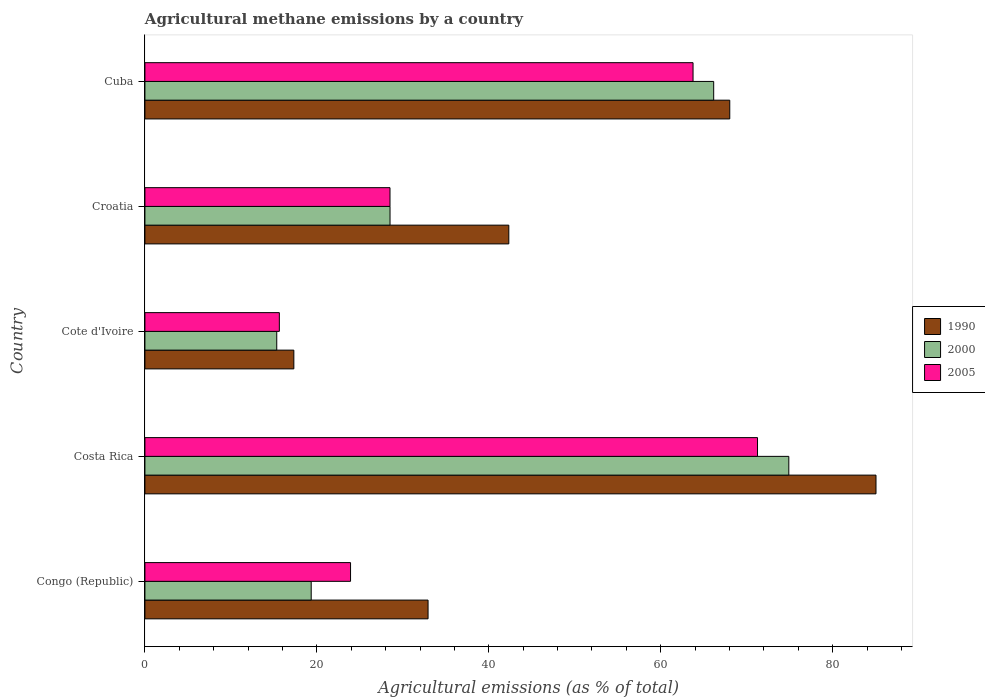How many bars are there on the 1st tick from the bottom?
Keep it short and to the point. 3. What is the label of the 1st group of bars from the top?
Provide a short and direct response. Cuba. In how many cases, is the number of bars for a given country not equal to the number of legend labels?
Your answer should be very brief. 0. What is the amount of agricultural methane emitted in 2000 in Croatia?
Provide a short and direct response. 28.51. Across all countries, what is the maximum amount of agricultural methane emitted in 2000?
Your answer should be very brief. 74.89. Across all countries, what is the minimum amount of agricultural methane emitted in 2000?
Offer a terse response. 15.33. In which country was the amount of agricultural methane emitted in 1990 minimum?
Give a very brief answer. Cote d'Ivoire. What is the total amount of agricultural methane emitted in 2000 in the graph?
Offer a very short reply. 204.24. What is the difference between the amount of agricultural methane emitted in 2000 in Cote d'Ivoire and that in Cuba?
Your response must be concise. -50.82. What is the difference between the amount of agricultural methane emitted in 2005 in Congo (Republic) and the amount of agricultural methane emitted in 1990 in Costa Rica?
Make the answer very short. -61.12. What is the average amount of agricultural methane emitted in 2005 per country?
Provide a short and direct response. 40.61. What is the difference between the amount of agricultural methane emitted in 2000 and amount of agricultural methane emitted in 2005 in Costa Rica?
Your answer should be very brief. 3.64. In how many countries, is the amount of agricultural methane emitted in 2005 greater than 64 %?
Keep it short and to the point. 1. What is the ratio of the amount of agricultural methane emitted in 2005 in Costa Rica to that in Cote d'Ivoire?
Keep it short and to the point. 4.56. Is the amount of agricultural methane emitted in 2000 in Congo (Republic) less than that in Croatia?
Provide a short and direct response. Yes. Is the difference between the amount of agricultural methane emitted in 2000 in Cote d'Ivoire and Croatia greater than the difference between the amount of agricultural methane emitted in 2005 in Cote d'Ivoire and Croatia?
Your answer should be very brief. No. What is the difference between the highest and the second highest amount of agricultural methane emitted in 2005?
Provide a succinct answer. 7.5. What is the difference between the highest and the lowest amount of agricultural methane emitted in 2005?
Your response must be concise. 55.62. In how many countries, is the amount of agricultural methane emitted in 1990 greater than the average amount of agricultural methane emitted in 1990 taken over all countries?
Provide a succinct answer. 2. Is the sum of the amount of agricultural methane emitted in 1990 in Congo (Republic) and Costa Rica greater than the maximum amount of agricultural methane emitted in 2005 across all countries?
Your answer should be compact. Yes. What does the 3rd bar from the bottom in Cuba represents?
Offer a terse response. 2005. How many bars are there?
Your answer should be compact. 15. Are all the bars in the graph horizontal?
Offer a terse response. Yes. How many countries are there in the graph?
Offer a very short reply. 5. Are the values on the major ticks of X-axis written in scientific E-notation?
Give a very brief answer. No. How many legend labels are there?
Your response must be concise. 3. How are the legend labels stacked?
Keep it short and to the point. Vertical. What is the title of the graph?
Keep it short and to the point. Agricultural methane emissions by a country. Does "1993" appear as one of the legend labels in the graph?
Keep it short and to the point. No. What is the label or title of the X-axis?
Keep it short and to the point. Agricultural emissions (as % of total). What is the Agricultural emissions (as % of total) in 1990 in Congo (Republic)?
Provide a succinct answer. 32.93. What is the Agricultural emissions (as % of total) of 2000 in Congo (Republic)?
Offer a very short reply. 19.34. What is the Agricultural emissions (as % of total) of 2005 in Congo (Republic)?
Give a very brief answer. 23.92. What is the Agricultural emissions (as % of total) of 1990 in Costa Rica?
Your answer should be very brief. 85.04. What is the Agricultural emissions (as % of total) in 2000 in Costa Rica?
Make the answer very short. 74.89. What is the Agricultural emissions (as % of total) of 2005 in Costa Rica?
Make the answer very short. 71.26. What is the Agricultural emissions (as % of total) in 1990 in Cote d'Ivoire?
Provide a succinct answer. 17.32. What is the Agricultural emissions (as % of total) in 2000 in Cote d'Ivoire?
Your response must be concise. 15.33. What is the Agricultural emissions (as % of total) in 2005 in Cote d'Ivoire?
Offer a terse response. 15.64. What is the Agricultural emissions (as % of total) of 1990 in Croatia?
Offer a terse response. 42.33. What is the Agricultural emissions (as % of total) of 2000 in Croatia?
Give a very brief answer. 28.51. What is the Agricultural emissions (as % of total) of 2005 in Croatia?
Offer a very short reply. 28.51. What is the Agricultural emissions (as % of total) of 1990 in Cuba?
Offer a terse response. 68.03. What is the Agricultural emissions (as % of total) in 2000 in Cuba?
Give a very brief answer. 66.16. What is the Agricultural emissions (as % of total) in 2005 in Cuba?
Your answer should be very brief. 63.76. Across all countries, what is the maximum Agricultural emissions (as % of total) of 1990?
Your answer should be compact. 85.04. Across all countries, what is the maximum Agricultural emissions (as % of total) of 2000?
Provide a short and direct response. 74.89. Across all countries, what is the maximum Agricultural emissions (as % of total) in 2005?
Your response must be concise. 71.26. Across all countries, what is the minimum Agricultural emissions (as % of total) in 1990?
Ensure brevity in your answer.  17.32. Across all countries, what is the minimum Agricultural emissions (as % of total) in 2000?
Give a very brief answer. 15.33. Across all countries, what is the minimum Agricultural emissions (as % of total) of 2005?
Your answer should be compact. 15.64. What is the total Agricultural emissions (as % of total) in 1990 in the graph?
Ensure brevity in your answer.  245.65. What is the total Agricultural emissions (as % of total) in 2000 in the graph?
Offer a terse response. 204.24. What is the total Agricultural emissions (as % of total) in 2005 in the graph?
Keep it short and to the point. 203.07. What is the difference between the Agricultural emissions (as % of total) of 1990 in Congo (Republic) and that in Costa Rica?
Provide a succinct answer. -52.1. What is the difference between the Agricultural emissions (as % of total) of 2000 in Congo (Republic) and that in Costa Rica?
Provide a succinct answer. -55.55. What is the difference between the Agricultural emissions (as % of total) in 2005 in Congo (Republic) and that in Costa Rica?
Ensure brevity in your answer.  -47.34. What is the difference between the Agricultural emissions (as % of total) in 1990 in Congo (Republic) and that in Cote d'Ivoire?
Your answer should be compact. 15.61. What is the difference between the Agricultural emissions (as % of total) in 2000 in Congo (Republic) and that in Cote d'Ivoire?
Give a very brief answer. 4.01. What is the difference between the Agricultural emissions (as % of total) in 2005 in Congo (Republic) and that in Cote d'Ivoire?
Give a very brief answer. 8.28. What is the difference between the Agricultural emissions (as % of total) of 1990 in Congo (Republic) and that in Croatia?
Give a very brief answer. -9.39. What is the difference between the Agricultural emissions (as % of total) of 2000 in Congo (Republic) and that in Croatia?
Give a very brief answer. -9.17. What is the difference between the Agricultural emissions (as % of total) of 2005 in Congo (Republic) and that in Croatia?
Your response must be concise. -4.59. What is the difference between the Agricultural emissions (as % of total) of 1990 in Congo (Republic) and that in Cuba?
Give a very brief answer. -35.09. What is the difference between the Agricultural emissions (as % of total) in 2000 in Congo (Republic) and that in Cuba?
Ensure brevity in your answer.  -46.81. What is the difference between the Agricultural emissions (as % of total) of 2005 in Congo (Republic) and that in Cuba?
Give a very brief answer. -39.84. What is the difference between the Agricultural emissions (as % of total) in 1990 in Costa Rica and that in Cote d'Ivoire?
Your answer should be very brief. 67.71. What is the difference between the Agricultural emissions (as % of total) in 2000 in Costa Rica and that in Cote d'Ivoire?
Keep it short and to the point. 59.56. What is the difference between the Agricultural emissions (as % of total) in 2005 in Costa Rica and that in Cote d'Ivoire?
Give a very brief answer. 55.62. What is the difference between the Agricultural emissions (as % of total) of 1990 in Costa Rica and that in Croatia?
Your answer should be very brief. 42.71. What is the difference between the Agricultural emissions (as % of total) of 2000 in Costa Rica and that in Croatia?
Your response must be concise. 46.38. What is the difference between the Agricultural emissions (as % of total) of 2005 in Costa Rica and that in Croatia?
Your response must be concise. 42.75. What is the difference between the Agricultural emissions (as % of total) in 1990 in Costa Rica and that in Cuba?
Provide a short and direct response. 17.01. What is the difference between the Agricultural emissions (as % of total) in 2000 in Costa Rica and that in Cuba?
Give a very brief answer. 8.74. What is the difference between the Agricultural emissions (as % of total) of 2005 in Costa Rica and that in Cuba?
Make the answer very short. 7.5. What is the difference between the Agricultural emissions (as % of total) of 1990 in Cote d'Ivoire and that in Croatia?
Give a very brief answer. -25. What is the difference between the Agricultural emissions (as % of total) in 2000 in Cote d'Ivoire and that in Croatia?
Ensure brevity in your answer.  -13.18. What is the difference between the Agricultural emissions (as % of total) in 2005 in Cote d'Ivoire and that in Croatia?
Make the answer very short. -12.87. What is the difference between the Agricultural emissions (as % of total) in 1990 in Cote d'Ivoire and that in Cuba?
Keep it short and to the point. -50.7. What is the difference between the Agricultural emissions (as % of total) in 2000 in Cote d'Ivoire and that in Cuba?
Provide a short and direct response. -50.82. What is the difference between the Agricultural emissions (as % of total) of 2005 in Cote d'Ivoire and that in Cuba?
Make the answer very short. -48.12. What is the difference between the Agricultural emissions (as % of total) of 1990 in Croatia and that in Cuba?
Make the answer very short. -25.7. What is the difference between the Agricultural emissions (as % of total) in 2000 in Croatia and that in Cuba?
Provide a short and direct response. -37.65. What is the difference between the Agricultural emissions (as % of total) in 2005 in Croatia and that in Cuba?
Provide a short and direct response. -35.25. What is the difference between the Agricultural emissions (as % of total) in 1990 in Congo (Republic) and the Agricultural emissions (as % of total) in 2000 in Costa Rica?
Your response must be concise. -41.96. What is the difference between the Agricultural emissions (as % of total) in 1990 in Congo (Republic) and the Agricultural emissions (as % of total) in 2005 in Costa Rica?
Keep it short and to the point. -38.32. What is the difference between the Agricultural emissions (as % of total) in 2000 in Congo (Republic) and the Agricultural emissions (as % of total) in 2005 in Costa Rica?
Offer a terse response. -51.91. What is the difference between the Agricultural emissions (as % of total) in 1990 in Congo (Republic) and the Agricultural emissions (as % of total) in 2000 in Cote d'Ivoire?
Provide a short and direct response. 17.6. What is the difference between the Agricultural emissions (as % of total) of 1990 in Congo (Republic) and the Agricultural emissions (as % of total) of 2005 in Cote d'Ivoire?
Ensure brevity in your answer.  17.3. What is the difference between the Agricultural emissions (as % of total) in 2000 in Congo (Republic) and the Agricultural emissions (as % of total) in 2005 in Cote d'Ivoire?
Offer a very short reply. 3.71. What is the difference between the Agricultural emissions (as % of total) in 1990 in Congo (Republic) and the Agricultural emissions (as % of total) in 2000 in Croatia?
Ensure brevity in your answer.  4.42. What is the difference between the Agricultural emissions (as % of total) in 1990 in Congo (Republic) and the Agricultural emissions (as % of total) in 2005 in Croatia?
Offer a very short reply. 4.43. What is the difference between the Agricultural emissions (as % of total) of 2000 in Congo (Republic) and the Agricultural emissions (as % of total) of 2005 in Croatia?
Provide a succinct answer. -9.16. What is the difference between the Agricultural emissions (as % of total) of 1990 in Congo (Republic) and the Agricultural emissions (as % of total) of 2000 in Cuba?
Offer a terse response. -33.22. What is the difference between the Agricultural emissions (as % of total) in 1990 in Congo (Republic) and the Agricultural emissions (as % of total) in 2005 in Cuba?
Provide a succinct answer. -30.82. What is the difference between the Agricultural emissions (as % of total) of 2000 in Congo (Republic) and the Agricultural emissions (as % of total) of 2005 in Cuba?
Keep it short and to the point. -44.41. What is the difference between the Agricultural emissions (as % of total) of 1990 in Costa Rica and the Agricultural emissions (as % of total) of 2000 in Cote d'Ivoire?
Your answer should be compact. 69.7. What is the difference between the Agricultural emissions (as % of total) of 1990 in Costa Rica and the Agricultural emissions (as % of total) of 2005 in Cote d'Ivoire?
Give a very brief answer. 69.4. What is the difference between the Agricultural emissions (as % of total) of 2000 in Costa Rica and the Agricultural emissions (as % of total) of 2005 in Cote d'Ivoire?
Make the answer very short. 59.26. What is the difference between the Agricultural emissions (as % of total) of 1990 in Costa Rica and the Agricultural emissions (as % of total) of 2000 in Croatia?
Your response must be concise. 56.53. What is the difference between the Agricultural emissions (as % of total) in 1990 in Costa Rica and the Agricultural emissions (as % of total) in 2005 in Croatia?
Offer a terse response. 56.53. What is the difference between the Agricultural emissions (as % of total) in 2000 in Costa Rica and the Agricultural emissions (as % of total) in 2005 in Croatia?
Make the answer very short. 46.39. What is the difference between the Agricultural emissions (as % of total) in 1990 in Costa Rica and the Agricultural emissions (as % of total) in 2000 in Cuba?
Offer a very short reply. 18.88. What is the difference between the Agricultural emissions (as % of total) in 1990 in Costa Rica and the Agricultural emissions (as % of total) in 2005 in Cuba?
Offer a terse response. 21.28. What is the difference between the Agricultural emissions (as % of total) of 2000 in Costa Rica and the Agricultural emissions (as % of total) of 2005 in Cuba?
Give a very brief answer. 11.14. What is the difference between the Agricultural emissions (as % of total) in 1990 in Cote d'Ivoire and the Agricultural emissions (as % of total) in 2000 in Croatia?
Provide a succinct answer. -11.19. What is the difference between the Agricultural emissions (as % of total) of 1990 in Cote d'Ivoire and the Agricultural emissions (as % of total) of 2005 in Croatia?
Offer a terse response. -11.18. What is the difference between the Agricultural emissions (as % of total) in 2000 in Cote d'Ivoire and the Agricultural emissions (as % of total) in 2005 in Croatia?
Make the answer very short. -13.17. What is the difference between the Agricultural emissions (as % of total) of 1990 in Cote d'Ivoire and the Agricultural emissions (as % of total) of 2000 in Cuba?
Provide a succinct answer. -48.83. What is the difference between the Agricultural emissions (as % of total) in 1990 in Cote d'Ivoire and the Agricultural emissions (as % of total) in 2005 in Cuba?
Make the answer very short. -46.43. What is the difference between the Agricultural emissions (as % of total) of 2000 in Cote d'Ivoire and the Agricultural emissions (as % of total) of 2005 in Cuba?
Your response must be concise. -48.42. What is the difference between the Agricultural emissions (as % of total) in 1990 in Croatia and the Agricultural emissions (as % of total) in 2000 in Cuba?
Offer a very short reply. -23.83. What is the difference between the Agricultural emissions (as % of total) in 1990 in Croatia and the Agricultural emissions (as % of total) in 2005 in Cuba?
Provide a short and direct response. -21.43. What is the difference between the Agricultural emissions (as % of total) of 2000 in Croatia and the Agricultural emissions (as % of total) of 2005 in Cuba?
Provide a short and direct response. -35.24. What is the average Agricultural emissions (as % of total) in 1990 per country?
Your answer should be very brief. 49.13. What is the average Agricultural emissions (as % of total) in 2000 per country?
Provide a succinct answer. 40.85. What is the average Agricultural emissions (as % of total) in 2005 per country?
Your response must be concise. 40.61. What is the difference between the Agricultural emissions (as % of total) of 1990 and Agricultural emissions (as % of total) of 2000 in Congo (Republic)?
Your answer should be very brief. 13.59. What is the difference between the Agricultural emissions (as % of total) of 1990 and Agricultural emissions (as % of total) of 2005 in Congo (Republic)?
Give a very brief answer. 9.02. What is the difference between the Agricultural emissions (as % of total) of 2000 and Agricultural emissions (as % of total) of 2005 in Congo (Republic)?
Keep it short and to the point. -4.58. What is the difference between the Agricultural emissions (as % of total) in 1990 and Agricultural emissions (as % of total) in 2000 in Costa Rica?
Keep it short and to the point. 10.14. What is the difference between the Agricultural emissions (as % of total) of 1990 and Agricultural emissions (as % of total) of 2005 in Costa Rica?
Make the answer very short. 13.78. What is the difference between the Agricultural emissions (as % of total) in 2000 and Agricultural emissions (as % of total) in 2005 in Costa Rica?
Your answer should be compact. 3.64. What is the difference between the Agricultural emissions (as % of total) in 1990 and Agricultural emissions (as % of total) in 2000 in Cote d'Ivoire?
Ensure brevity in your answer.  1.99. What is the difference between the Agricultural emissions (as % of total) of 1990 and Agricultural emissions (as % of total) of 2005 in Cote d'Ivoire?
Your answer should be very brief. 1.69. What is the difference between the Agricultural emissions (as % of total) of 2000 and Agricultural emissions (as % of total) of 2005 in Cote d'Ivoire?
Give a very brief answer. -0.3. What is the difference between the Agricultural emissions (as % of total) of 1990 and Agricultural emissions (as % of total) of 2000 in Croatia?
Ensure brevity in your answer.  13.82. What is the difference between the Agricultural emissions (as % of total) of 1990 and Agricultural emissions (as % of total) of 2005 in Croatia?
Keep it short and to the point. 13.82. What is the difference between the Agricultural emissions (as % of total) of 2000 and Agricultural emissions (as % of total) of 2005 in Croatia?
Ensure brevity in your answer.  0. What is the difference between the Agricultural emissions (as % of total) of 1990 and Agricultural emissions (as % of total) of 2000 in Cuba?
Offer a terse response. 1.87. What is the difference between the Agricultural emissions (as % of total) in 1990 and Agricultural emissions (as % of total) in 2005 in Cuba?
Your answer should be very brief. 4.27. What is the difference between the Agricultural emissions (as % of total) in 2000 and Agricultural emissions (as % of total) in 2005 in Cuba?
Give a very brief answer. 2.4. What is the ratio of the Agricultural emissions (as % of total) in 1990 in Congo (Republic) to that in Costa Rica?
Provide a short and direct response. 0.39. What is the ratio of the Agricultural emissions (as % of total) of 2000 in Congo (Republic) to that in Costa Rica?
Make the answer very short. 0.26. What is the ratio of the Agricultural emissions (as % of total) in 2005 in Congo (Republic) to that in Costa Rica?
Your answer should be compact. 0.34. What is the ratio of the Agricultural emissions (as % of total) in 1990 in Congo (Republic) to that in Cote d'Ivoire?
Provide a short and direct response. 1.9. What is the ratio of the Agricultural emissions (as % of total) of 2000 in Congo (Republic) to that in Cote d'Ivoire?
Keep it short and to the point. 1.26. What is the ratio of the Agricultural emissions (as % of total) of 2005 in Congo (Republic) to that in Cote d'Ivoire?
Offer a terse response. 1.53. What is the ratio of the Agricultural emissions (as % of total) in 1990 in Congo (Republic) to that in Croatia?
Offer a very short reply. 0.78. What is the ratio of the Agricultural emissions (as % of total) in 2000 in Congo (Republic) to that in Croatia?
Make the answer very short. 0.68. What is the ratio of the Agricultural emissions (as % of total) of 2005 in Congo (Republic) to that in Croatia?
Your response must be concise. 0.84. What is the ratio of the Agricultural emissions (as % of total) in 1990 in Congo (Republic) to that in Cuba?
Ensure brevity in your answer.  0.48. What is the ratio of the Agricultural emissions (as % of total) of 2000 in Congo (Republic) to that in Cuba?
Offer a terse response. 0.29. What is the ratio of the Agricultural emissions (as % of total) in 2005 in Congo (Republic) to that in Cuba?
Provide a succinct answer. 0.38. What is the ratio of the Agricultural emissions (as % of total) of 1990 in Costa Rica to that in Cote d'Ivoire?
Your answer should be compact. 4.91. What is the ratio of the Agricultural emissions (as % of total) of 2000 in Costa Rica to that in Cote d'Ivoire?
Ensure brevity in your answer.  4.88. What is the ratio of the Agricultural emissions (as % of total) of 2005 in Costa Rica to that in Cote d'Ivoire?
Your answer should be very brief. 4.56. What is the ratio of the Agricultural emissions (as % of total) in 1990 in Costa Rica to that in Croatia?
Give a very brief answer. 2.01. What is the ratio of the Agricultural emissions (as % of total) of 2000 in Costa Rica to that in Croatia?
Provide a succinct answer. 2.63. What is the ratio of the Agricultural emissions (as % of total) of 2005 in Costa Rica to that in Croatia?
Offer a very short reply. 2.5. What is the ratio of the Agricultural emissions (as % of total) in 1990 in Costa Rica to that in Cuba?
Your answer should be compact. 1.25. What is the ratio of the Agricultural emissions (as % of total) of 2000 in Costa Rica to that in Cuba?
Offer a terse response. 1.13. What is the ratio of the Agricultural emissions (as % of total) in 2005 in Costa Rica to that in Cuba?
Your response must be concise. 1.12. What is the ratio of the Agricultural emissions (as % of total) in 1990 in Cote d'Ivoire to that in Croatia?
Provide a succinct answer. 0.41. What is the ratio of the Agricultural emissions (as % of total) of 2000 in Cote d'Ivoire to that in Croatia?
Give a very brief answer. 0.54. What is the ratio of the Agricultural emissions (as % of total) of 2005 in Cote d'Ivoire to that in Croatia?
Provide a succinct answer. 0.55. What is the ratio of the Agricultural emissions (as % of total) of 1990 in Cote d'Ivoire to that in Cuba?
Your answer should be very brief. 0.25. What is the ratio of the Agricultural emissions (as % of total) of 2000 in Cote d'Ivoire to that in Cuba?
Your response must be concise. 0.23. What is the ratio of the Agricultural emissions (as % of total) of 2005 in Cote d'Ivoire to that in Cuba?
Your response must be concise. 0.25. What is the ratio of the Agricultural emissions (as % of total) of 1990 in Croatia to that in Cuba?
Give a very brief answer. 0.62. What is the ratio of the Agricultural emissions (as % of total) of 2000 in Croatia to that in Cuba?
Make the answer very short. 0.43. What is the ratio of the Agricultural emissions (as % of total) in 2005 in Croatia to that in Cuba?
Make the answer very short. 0.45. What is the difference between the highest and the second highest Agricultural emissions (as % of total) of 1990?
Your answer should be compact. 17.01. What is the difference between the highest and the second highest Agricultural emissions (as % of total) in 2000?
Offer a terse response. 8.74. What is the difference between the highest and the second highest Agricultural emissions (as % of total) in 2005?
Offer a very short reply. 7.5. What is the difference between the highest and the lowest Agricultural emissions (as % of total) in 1990?
Your answer should be compact. 67.71. What is the difference between the highest and the lowest Agricultural emissions (as % of total) in 2000?
Provide a short and direct response. 59.56. What is the difference between the highest and the lowest Agricultural emissions (as % of total) in 2005?
Provide a succinct answer. 55.62. 